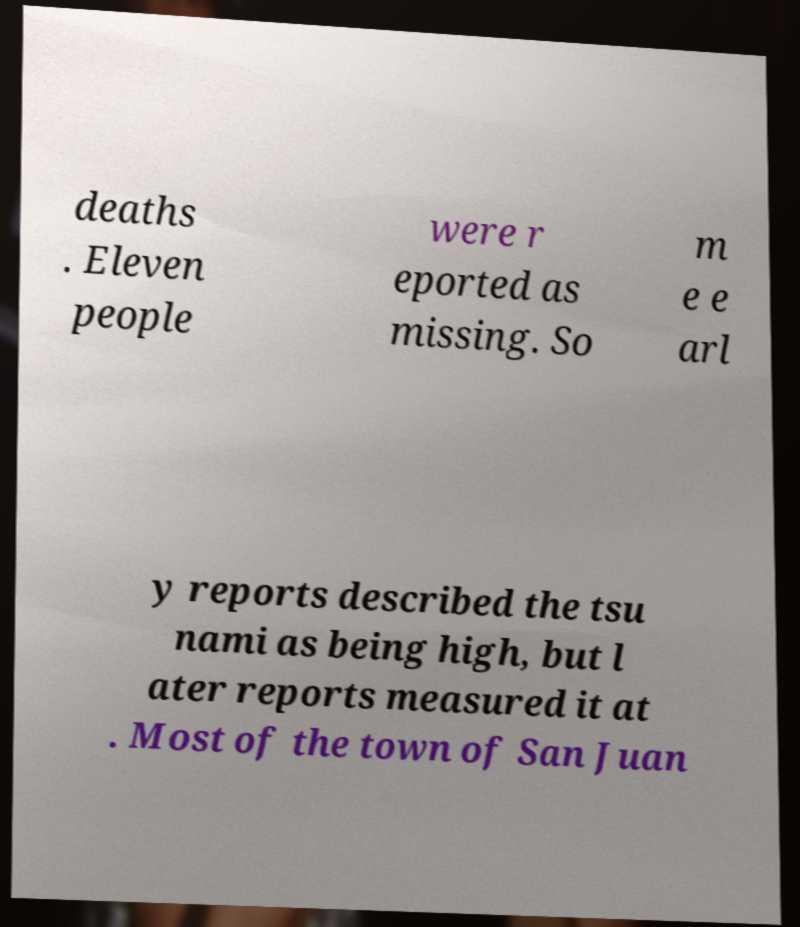Could you extract and type out the text from this image? deaths . Eleven people were r eported as missing. So m e e arl y reports described the tsu nami as being high, but l ater reports measured it at . Most of the town of San Juan 